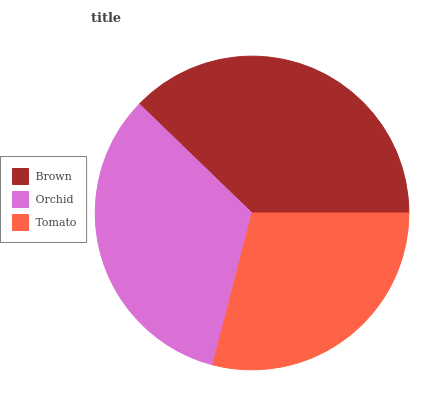Is Tomato the minimum?
Answer yes or no. Yes. Is Brown the maximum?
Answer yes or no. Yes. Is Orchid the minimum?
Answer yes or no. No. Is Orchid the maximum?
Answer yes or no. No. Is Brown greater than Orchid?
Answer yes or no. Yes. Is Orchid less than Brown?
Answer yes or no. Yes. Is Orchid greater than Brown?
Answer yes or no. No. Is Brown less than Orchid?
Answer yes or no. No. Is Orchid the high median?
Answer yes or no. Yes. Is Orchid the low median?
Answer yes or no. Yes. Is Brown the high median?
Answer yes or no. No. Is Tomato the low median?
Answer yes or no. No. 